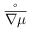Convert formula to latex. <formula><loc_0><loc_0><loc_500><loc_500>\overset { \circ } { \overline { \nabla \mu } }</formula> 